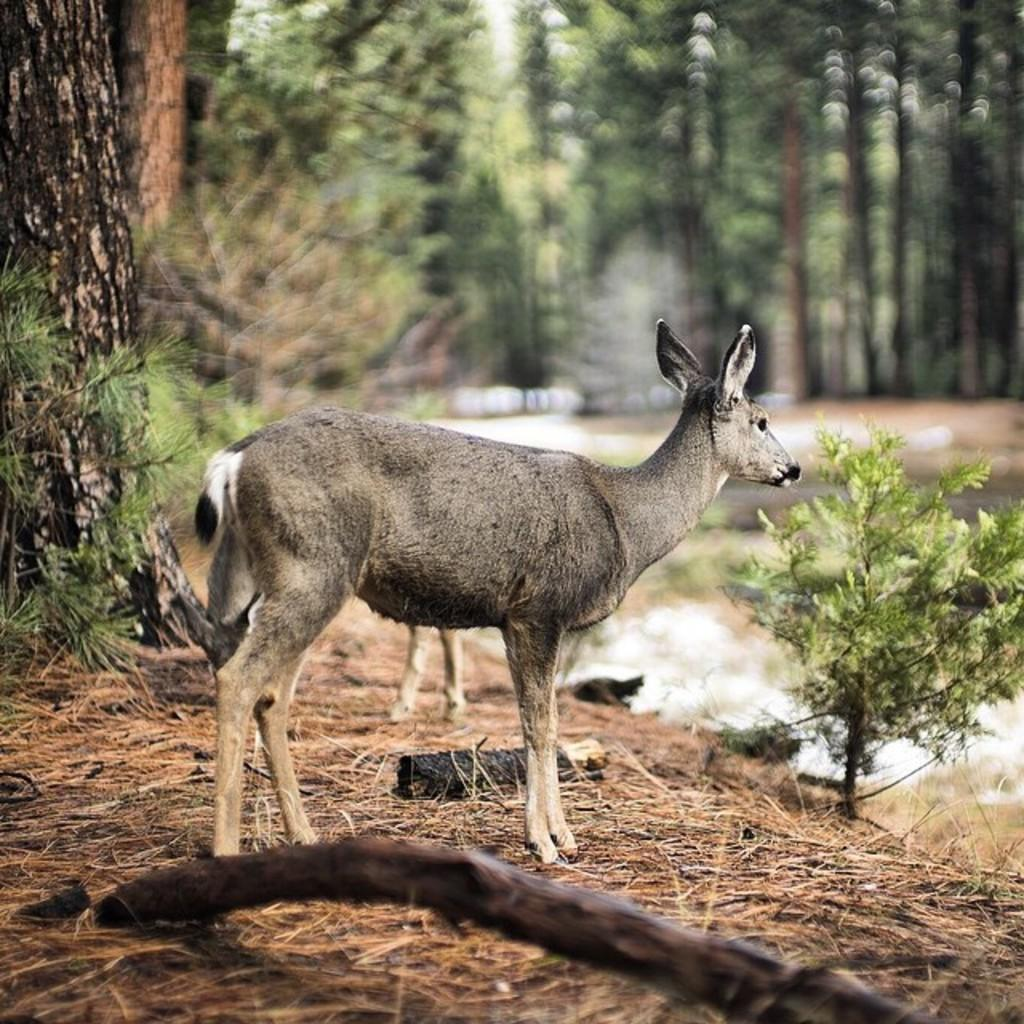What type of animals can be seen on the grass in the image? The image contains animals on the grass, but their specific type is not mentioned in the facts. What other elements can be seen in the image besides the animals? There are plants and wooden objects visible in the image. Can you describe the presence of smoke in the image? Yes, there is smoke visible in the image. How is the background of the image depicted? The background of the image is blurry, and trees are present in it. What type of lamp is casting a shade on the animals in the image? There is no lamp or shade present in the image; it features animals on the grass, plants, wooden objects, smoke, and a blurry background with trees. What kind of stone is being used as a seat for the animals in the image? There is no stone or seat for the animals mentioned in the image; it only shows animals on the grass, plants, wooden objects, smoke, and a blurry background with trees. 